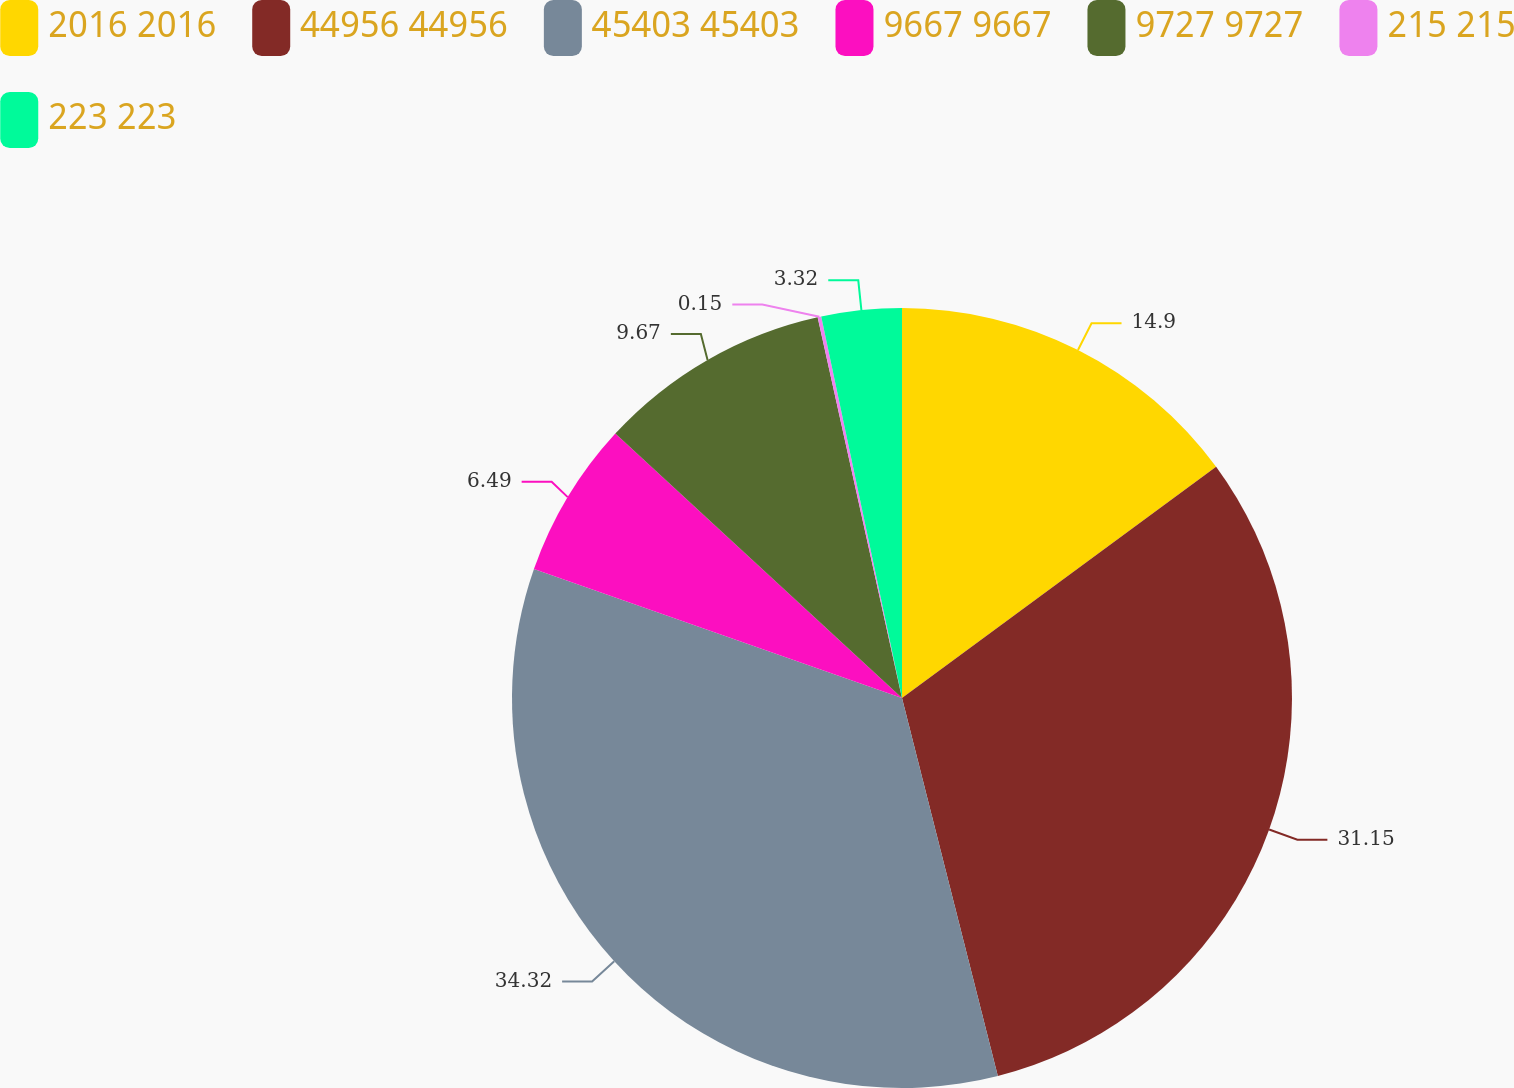Convert chart to OTSL. <chart><loc_0><loc_0><loc_500><loc_500><pie_chart><fcel>2016 2016<fcel>44956 44956<fcel>45403 45403<fcel>9667 9667<fcel>9727 9727<fcel>215 215<fcel>223 223<nl><fcel>14.9%<fcel>31.14%<fcel>34.31%<fcel>6.49%<fcel>9.67%<fcel>0.15%<fcel>3.32%<nl></chart> 